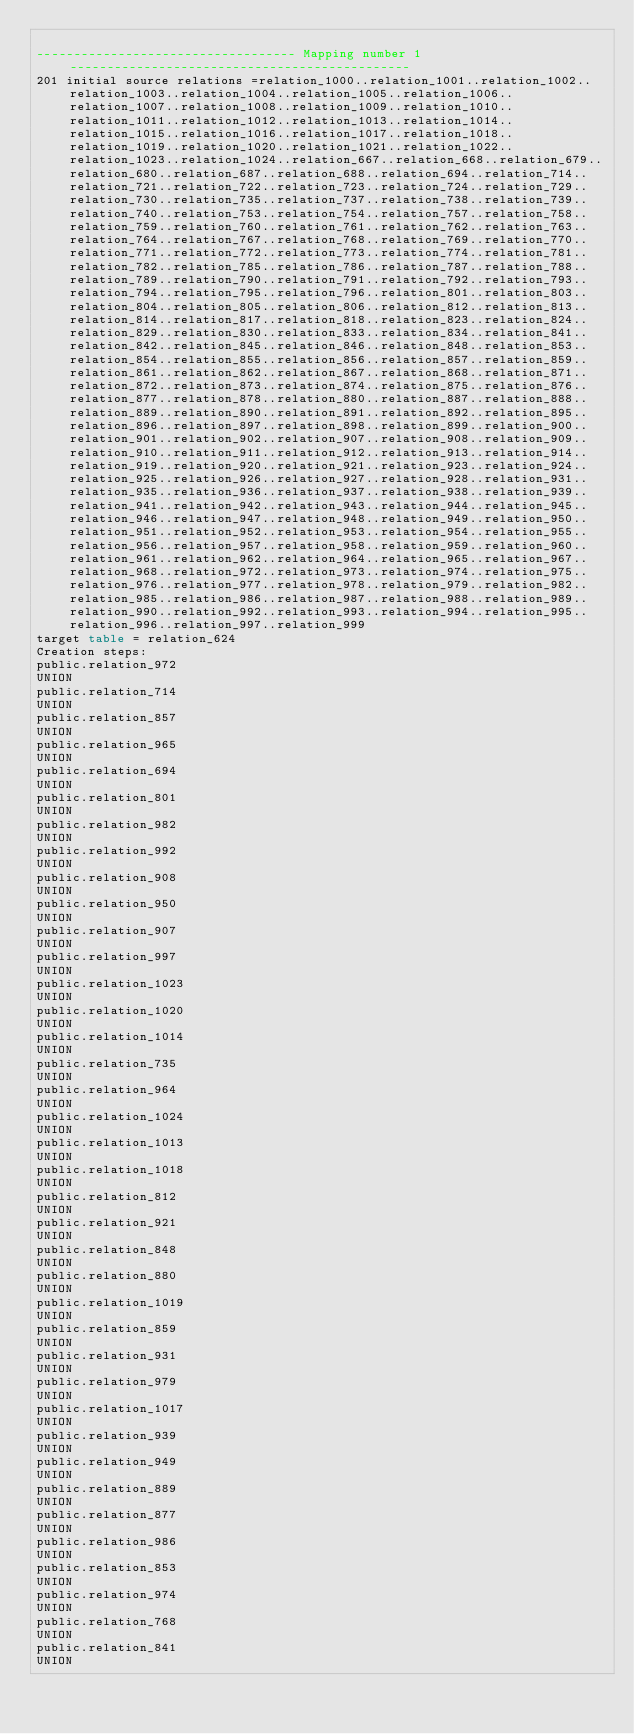<code> <loc_0><loc_0><loc_500><loc_500><_SQL_>
----------------------------------- Mapping number 1 ----------------------------------------------
201 initial source relations =relation_1000..relation_1001..relation_1002..relation_1003..relation_1004..relation_1005..relation_1006..relation_1007..relation_1008..relation_1009..relation_1010..relation_1011..relation_1012..relation_1013..relation_1014..relation_1015..relation_1016..relation_1017..relation_1018..relation_1019..relation_1020..relation_1021..relation_1022..relation_1023..relation_1024..relation_667..relation_668..relation_679..relation_680..relation_687..relation_688..relation_694..relation_714..relation_721..relation_722..relation_723..relation_724..relation_729..relation_730..relation_735..relation_737..relation_738..relation_739..relation_740..relation_753..relation_754..relation_757..relation_758..relation_759..relation_760..relation_761..relation_762..relation_763..relation_764..relation_767..relation_768..relation_769..relation_770..relation_771..relation_772..relation_773..relation_774..relation_781..relation_782..relation_785..relation_786..relation_787..relation_788..relation_789..relation_790..relation_791..relation_792..relation_793..relation_794..relation_795..relation_796..relation_801..relation_803..relation_804..relation_805..relation_806..relation_812..relation_813..relation_814..relation_817..relation_818..relation_823..relation_824..relation_829..relation_830..relation_833..relation_834..relation_841..relation_842..relation_845..relation_846..relation_848..relation_853..relation_854..relation_855..relation_856..relation_857..relation_859..relation_861..relation_862..relation_867..relation_868..relation_871..relation_872..relation_873..relation_874..relation_875..relation_876..relation_877..relation_878..relation_880..relation_887..relation_888..relation_889..relation_890..relation_891..relation_892..relation_895..relation_896..relation_897..relation_898..relation_899..relation_900..relation_901..relation_902..relation_907..relation_908..relation_909..relation_910..relation_911..relation_912..relation_913..relation_914..relation_919..relation_920..relation_921..relation_923..relation_924..relation_925..relation_926..relation_927..relation_928..relation_931..relation_935..relation_936..relation_937..relation_938..relation_939..relation_941..relation_942..relation_943..relation_944..relation_945..relation_946..relation_947..relation_948..relation_949..relation_950..relation_951..relation_952..relation_953..relation_954..relation_955..relation_956..relation_957..relation_958..relation_959..relation_960..relation_961..relation_962..relation_964..relation_965..relation_967..relation_968..relation_972..relation_973..relation_974..relation_975..relation_976..relation_977..relation_978..relation_979..relation_982..relation_985..relation_986..relation_987..relation_988..relation_989..relation_990..relation_992..relation_993..relation_994..relation_995..relation_996..relation_997..relation_999
target table = relation_624
Creation steps:
public.relation_972
UNION
public.relation_714
UNION
public.relation_857
UNION
public.relation_965
UNION
public.relation_694
UNION
public.relation_801
UNION
public.relation_982
UNION
public.relation_992
UNION
public.relation_908
UNION
public.relation_950
UNION
public.relation_907
UNION
public.relation_997
UNION
public.relation_1023
UNION
public.relation_1020
UNION
public.relation_1014
UNION
public.relation_735
UNION
public.relation_964
UNION
public.relation_1024
UNION
public.relation_1013
UNION
public.relation_1018
UNION
public.relation_812
UNION
public.relation_921
UNION
public.relation_848
UNION
public.relation_880
UNION
public.relation_1019
UNION
public.relation_859
UNION
public.relation_931
UNION
public.relation_979
UNION
public.relation_1017
UNION
public.relation_939
UNION
public.relation_949
UNION
public.relation_889
UNION
public.relation_877
UNION
public.relation_986
UNION
public.relation_853
UNION
public.relation_974
UNION
public.relation_768
UNION
public.relation_841
UNION</code> 